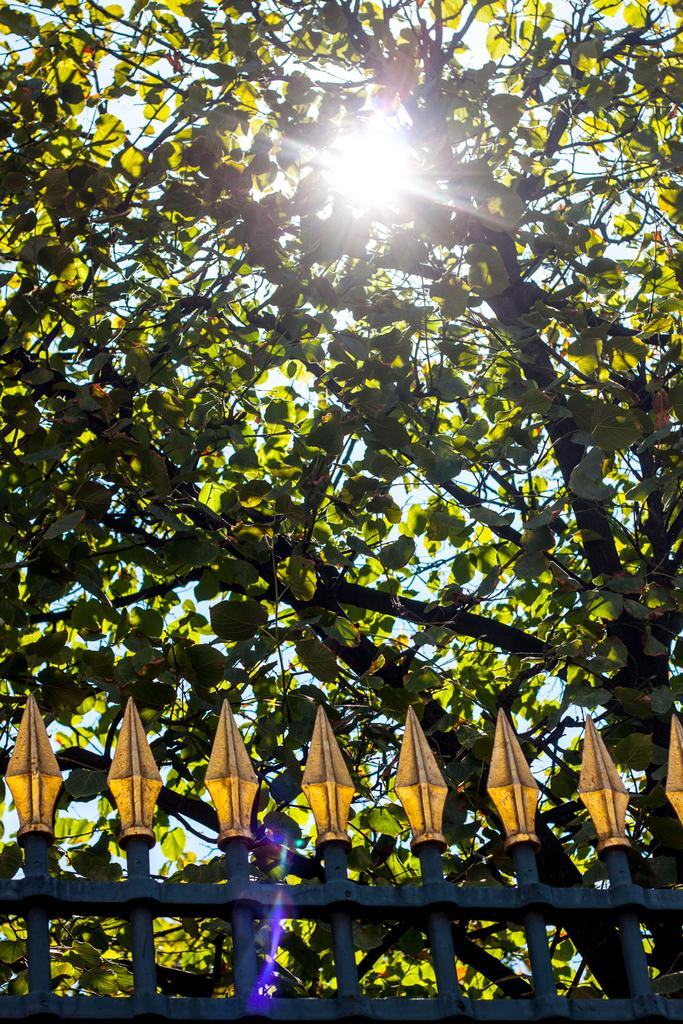What is located at the bottom of the image? The railing is visible at the bottom of the image. What is situated at the top of the railing? There is a tree at the top of the railing. What can be seen at the top of the image? Sunlight is visible at the top of the image. How many clovers are growing on the railing in the image? There are no clovers present in the image; it features a tree on the railing. What type of drain is visible at the top of the image? There is no drain present in the image; it features sunlight at the top. 